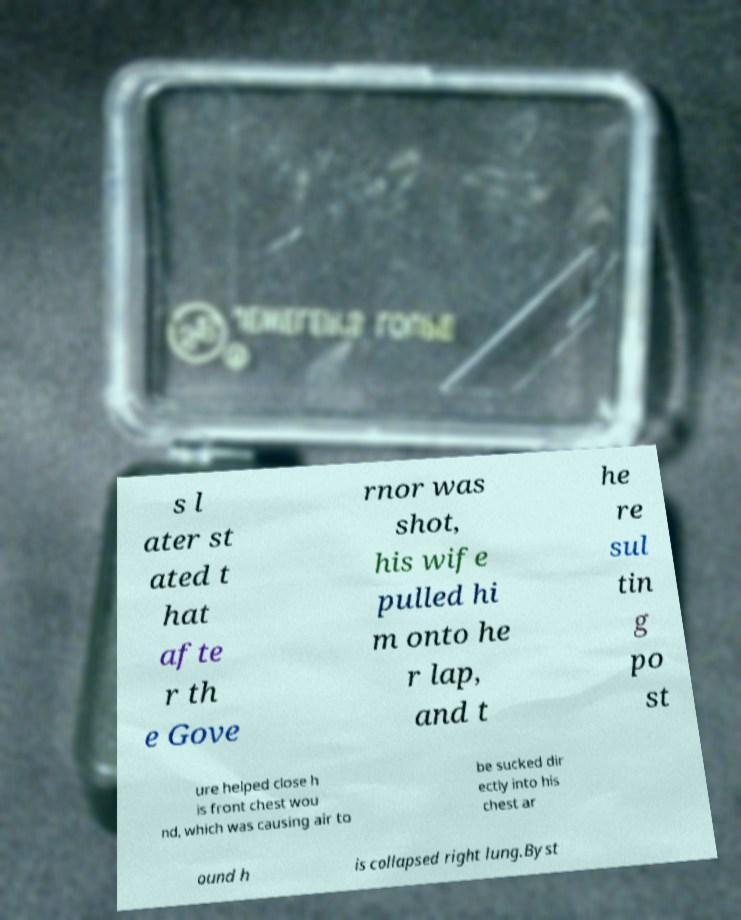Please read and relay the text visible in this image. What does it say? s l ater st ated t hat afte r th e Gove rnor was shot, his wife pulled hi m onto he r lap, and t he re sul tin g po st ure helped close h is front chest wou nd, which was causing air to be sucked dir ectly into his chest ar ound h is collapsed right lung.Byst 